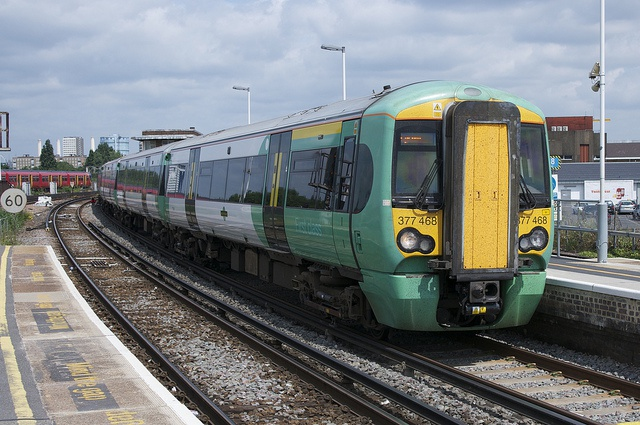Describe the objects in this image and their specific colors. I can see train in lightgray, black, purple, teal, and darkgray tones, train in lightgray, brown, maroon, gray, and black tones, car in lightgray and gray tones, car in lightgray, gray, and darkgray tones, and car in lightgray, gray, and darkgray tones in this image. 